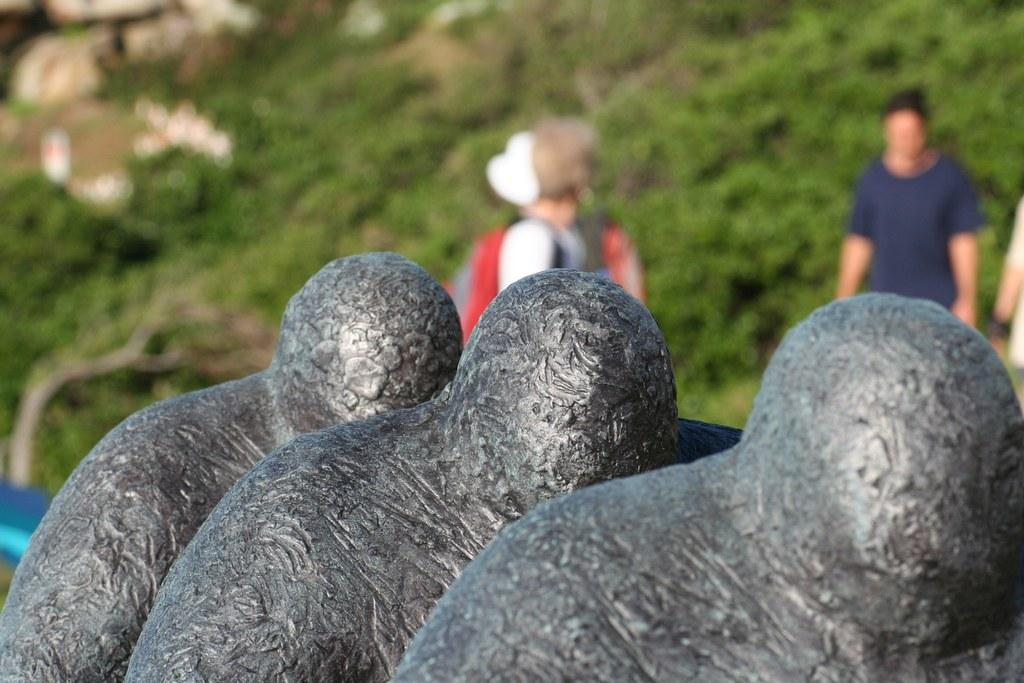What type of artwork can be seen in the image? There are sculptures in the image. Can you describe the background of the image? The background of the image is blurry. Are there any people present in the image? Yes, there are people visible in the background of the image. What type of slope can be seen in the image? There is no slope present in the image; it features sculptures and people in a blurry background. How many pairs of shoes are visible in the image? There is no mention of shoes in the image, so it is not possible to determine how many pairs are visible. 